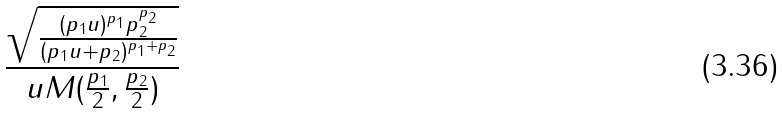Convert formula to latex. <formula><loc_0><loc_0><loc_500><loc_500>\frac { \sqrt { \frac { ( p _ { 1 } u ) ^ { p _ { 1 } } p _ { 2 } ^ { p _ { 2 } } } { ( p _ { 1 } u + p _ { 2 } ) ^ { p _ { 1 } + p _ { 2 } } } } } { u M ( \frac { p _ { 1 } } { 2 } , \frac { p _ { 2 } } { 2 } ) }</formula> 